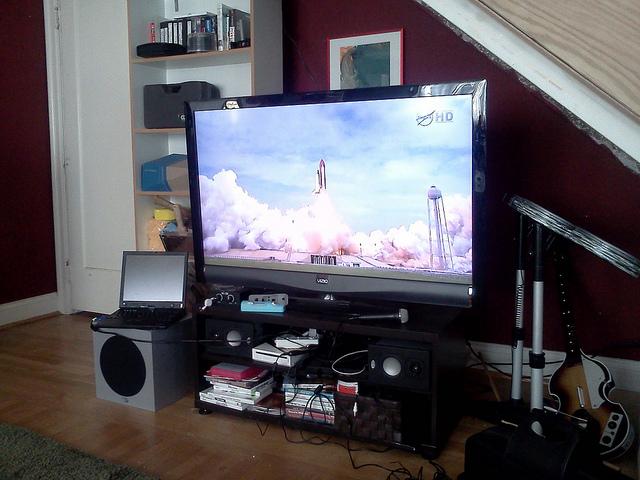What color is the wall in the room?
Keep it brief. Red. What is showing on the TV?
Give a very brief answer. Rocket launch. Is there more than one speaker?
Keep it brief. Yes. What scene is on TV?
Be succinct. Shuttle launch. What's on the floor?
Give a very brief answer. Rug. 